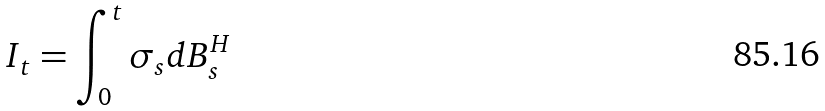<formula> <loc_0><loc_0><loc_500><loc_500>I _ { t } = \int _ { 0 } ^ { t } \sigma _ { s } d B ^ { H } _ { s }</formula> 